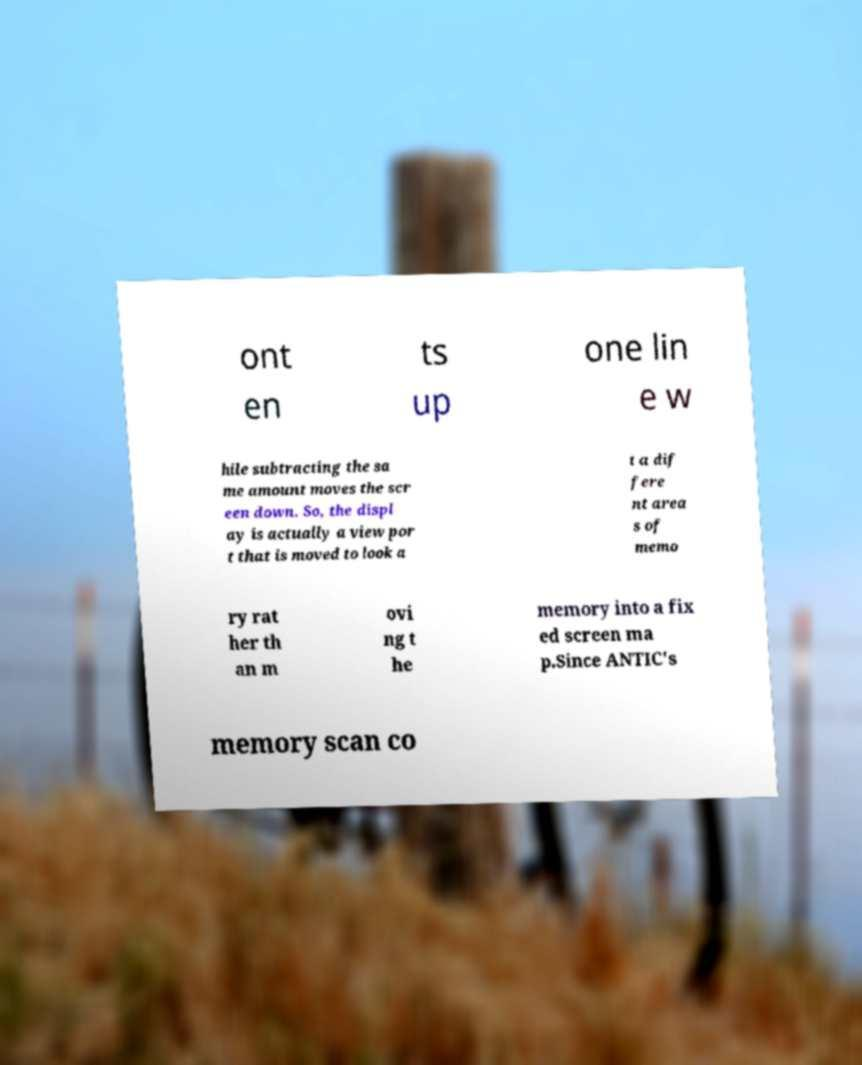I need the written content from this picture converted into text. Can you do that? ont en ts up one lin e w hile subtracting the sa me amount moves the scr een down. So, the displ ay is actually a view por t that is moved to look a t a dif fere nt area s of memo ry rat her th an m ovi ng t he memory into a fix ed screen ma p.Since ANTIC's memory scan co 